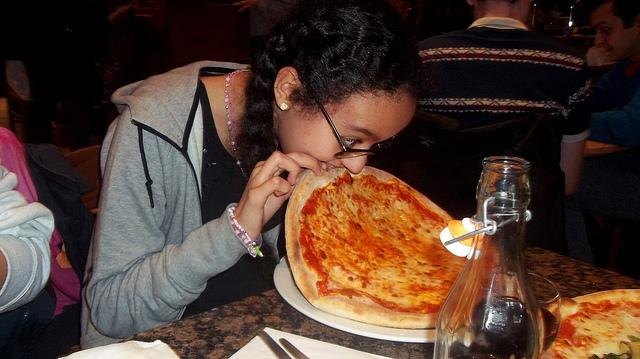What direction are the stripes on the person's shirt going? horizontal 